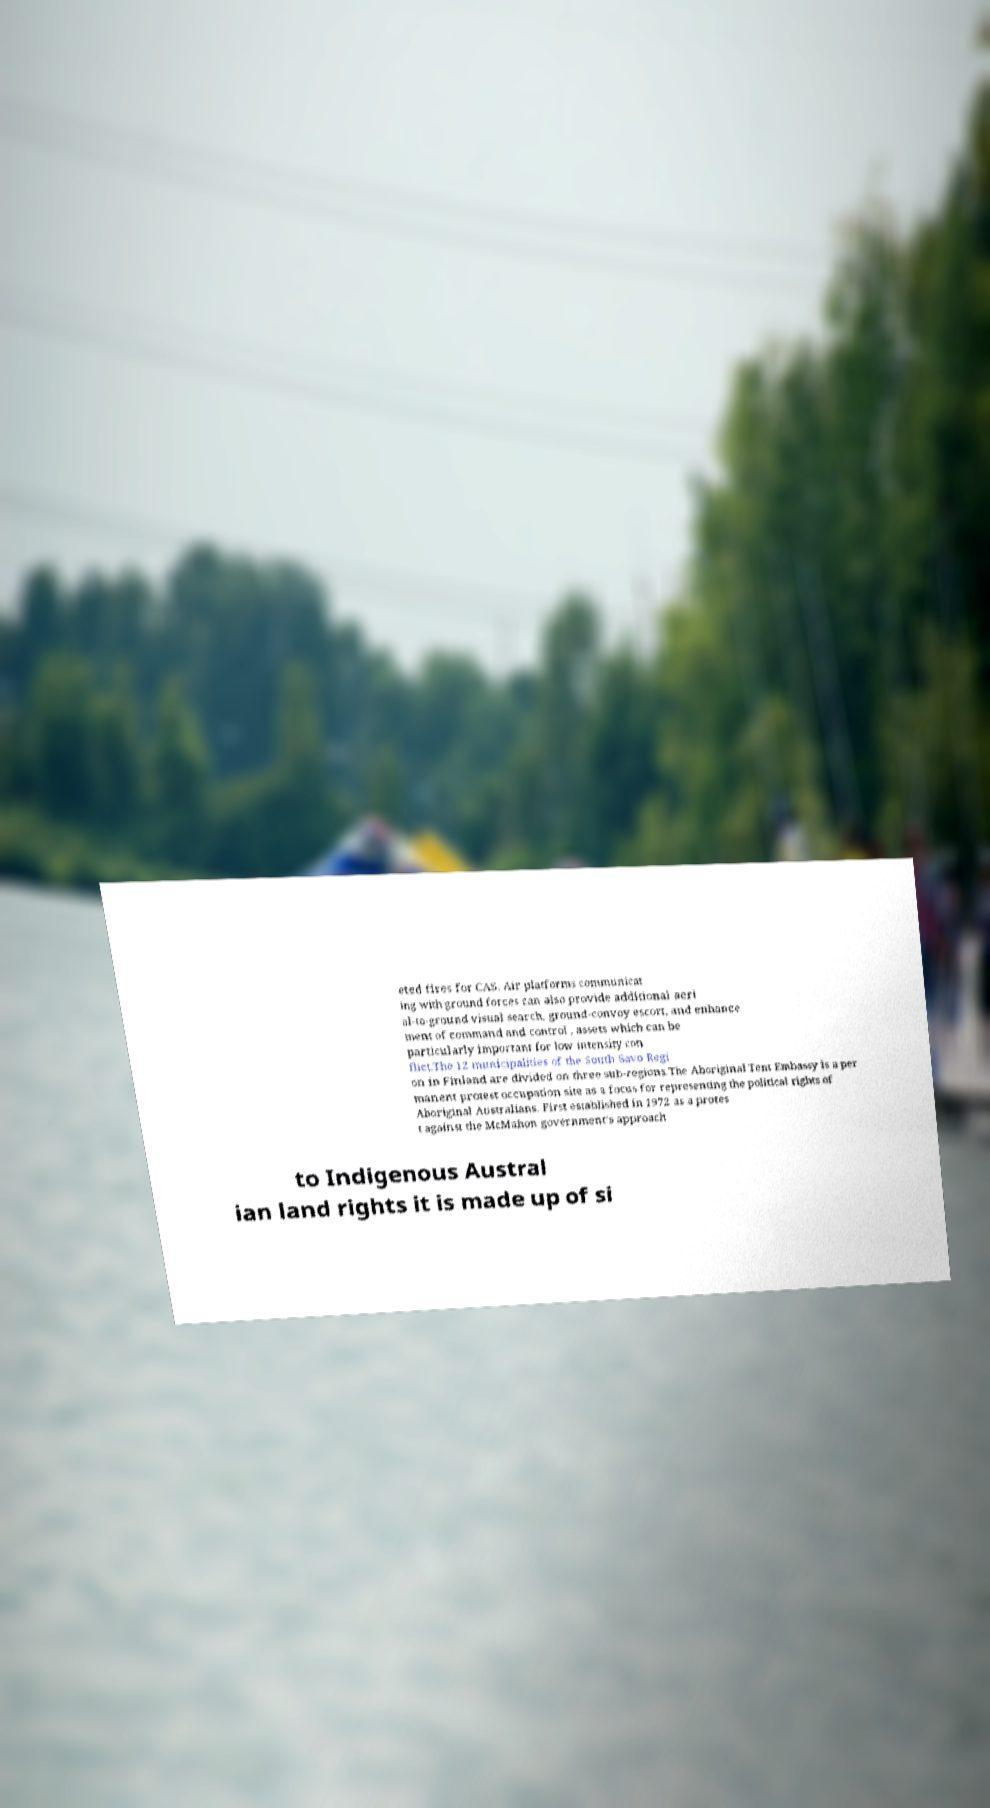Could you extract and type out the text from this image? eted fires for CAS. Air platforms communicat ing with ground forces can also provide additional aeri al-to-ground visual search, ground-convoy escort, and enhance ment of command and control , assets which can be particularly important for low intensity con flict.The 12 municipalities of the South Savo Regi on in Finland are divided on three sub-regions.The Aboriginal Tent Embassy is a per manent protest occupation site as a focus for representing the political rights of Aboriginal Australians. First established in 1972 as a protes t against the McMahon government’s approach to Indigenous Austral ian land rights it is made up of si 